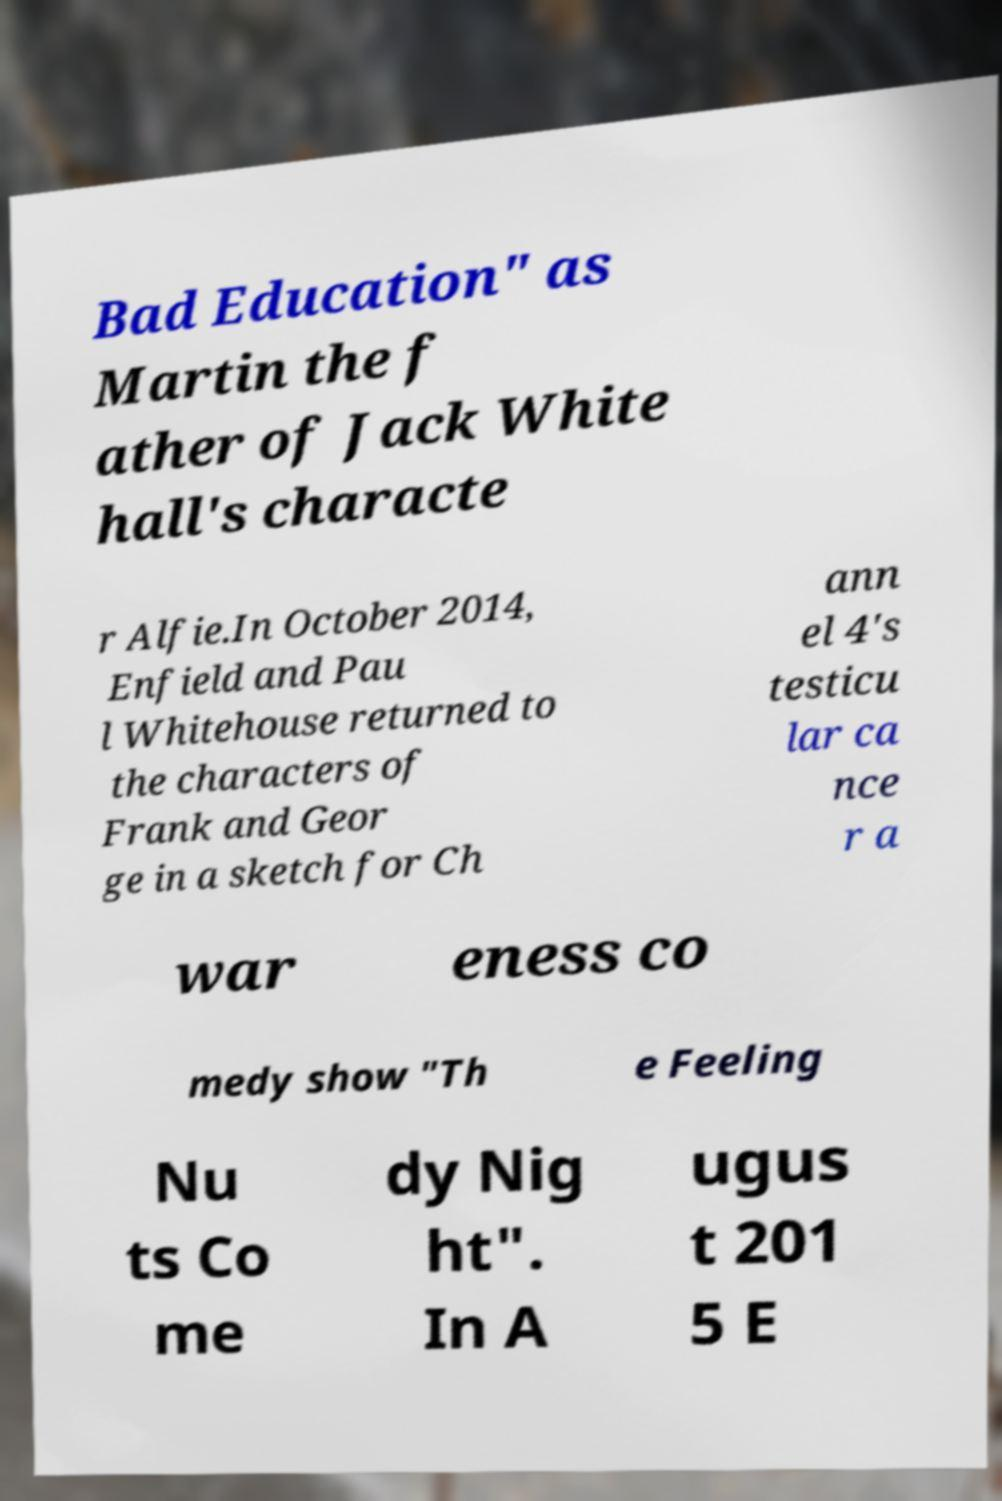Please identify and transcribe the text found in this image. Bad Education" as Martin the f ather of Jack White hall's characte r Alfie.In October 2014, Enfield and Pau l Whitehouse returned to the characters of Frank and Geor ge in a sketch for Ch ann el 4's testicu lar ca nce r a war eness co medy show "Th e Feeling Nu ts Co me dy Nig ht". In A ugus t 201 5 E 